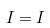Convert formula to latex. <formula><loc_0><loc_0><loc_500><loc_500>I = I</formula> 